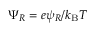Convert formula to latex. <formula><loc_0><loc_0><loc_500><loc_500>\Psi _ { R } = e \psi _ { R } / k _ { B } T</formula> 